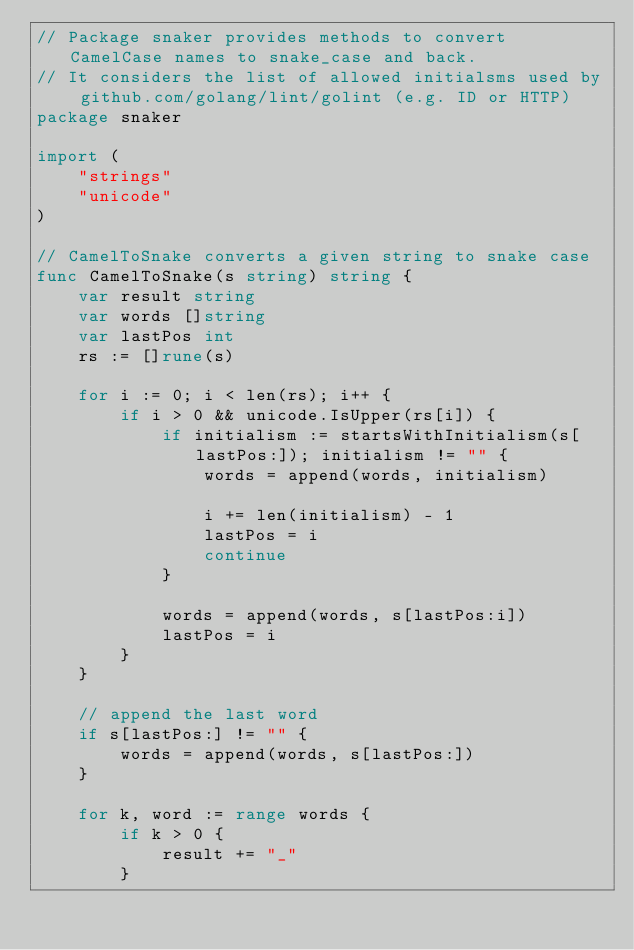Convert code to text. <code><loc_0><loc_0><loc_500><loc_500><_Go_>// Package snaker provides methods to convert CamelCase names to snake_case and back.
// It considers the list of allowed initialsms used by github.com/golang/lint/golint (e.g. ID or HTTP)
package snaker

import (
	"strings"
	"unicode"
)

// CamelToSnake converts a given string to snake case
func CamelToSnake(s string) string {
	var result string
	var words []string
	var lastPos int
	rs := []rune(s)

	for i := 0; i < len(rs); i++ {
		if i > 0 && unicode.IsUpper(rs[i]) {
			if initialism := startsWithInitialism(s[lastPos:]); initialism != "" {
				words = append(words, initialism)

				i += len(initialism) - 1
				lastPos = i
				continue
			}

			words = append(words, s[lastPos:i])
			lastPos = i
		}
	}

	// append the last word
	if s[lastPos:] != "" {
		words = append(words, s[lastPos:])
	}

	for k, word := range words {
		if k > 0 {
			result += "_"
		}
</code> 